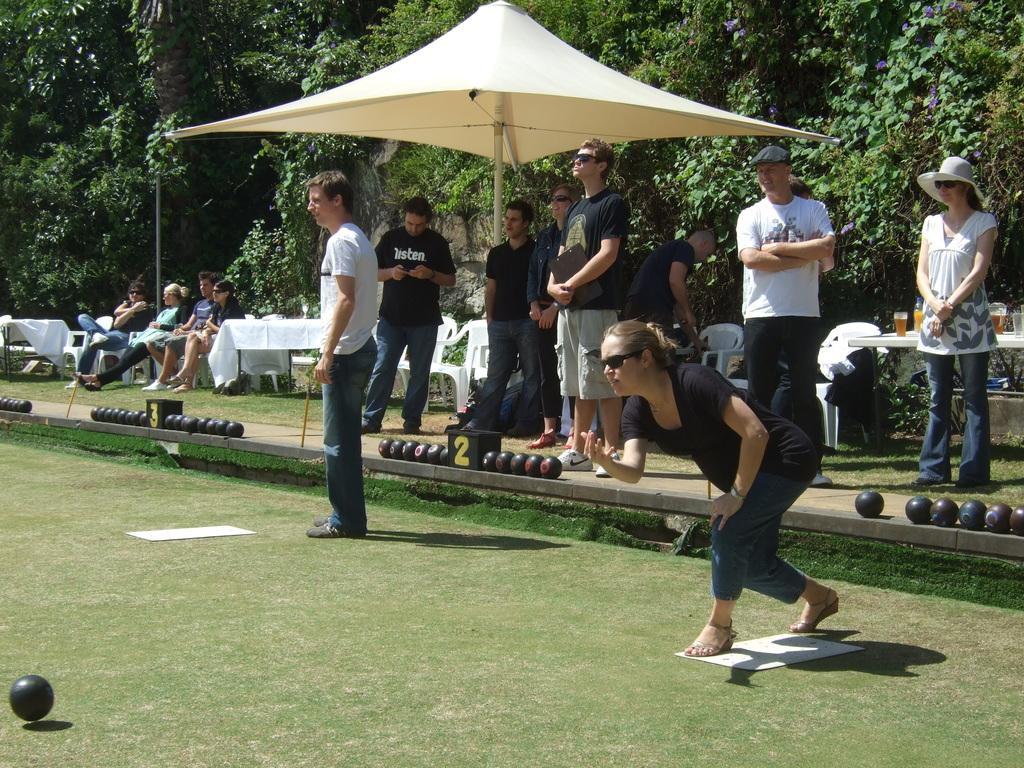Describe this image in one or two sentences. In this picture we can see there are groups of people. Behind the people there are balls, chairs, stall and a table. On the table there are glasses. Behind the stall, there are trees. 